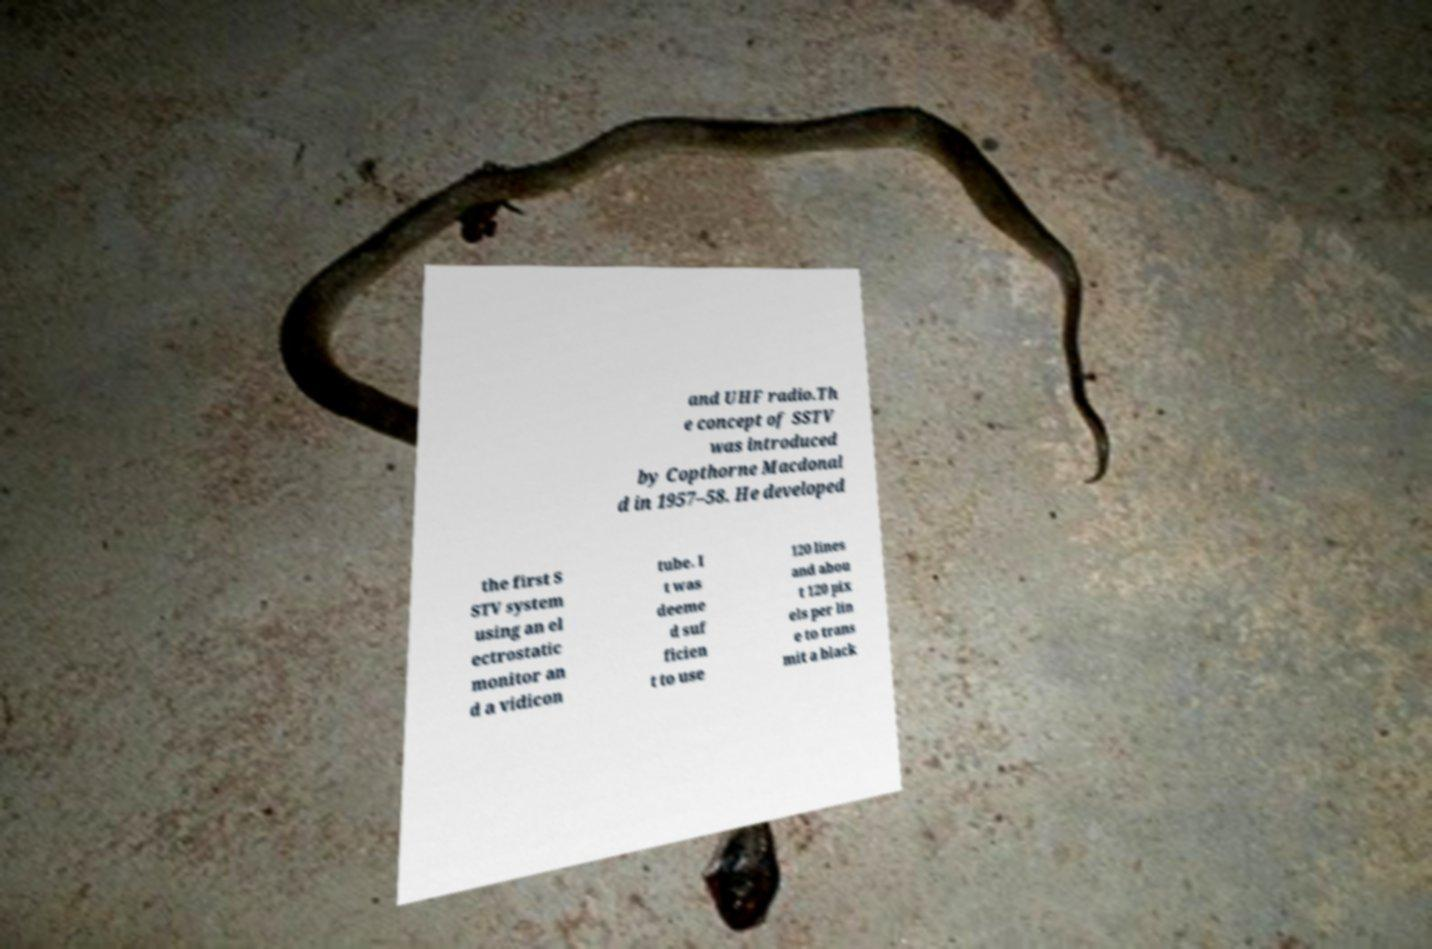What messages or text are displayed in this image? I need them in a readable, typed format. and UHF radio.Th e concept of SSTV was introduced by Copthorne Macdonal d in 1957–58. He developed the first S STV system using an el ectrostatic monitor an d a vidicon tube. I t was deeme d suf ficien t to use 120 lines and abou t 120 pix els per lin e to trans mit a black 